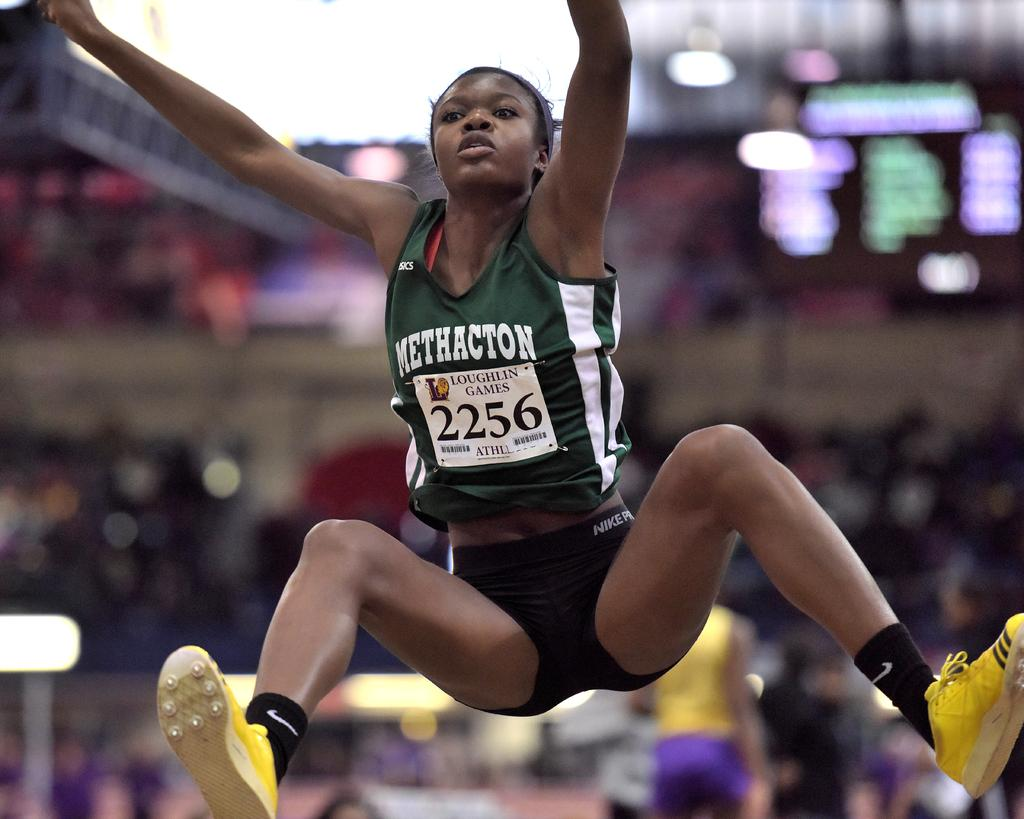<image>
Describe the image concisely. A female athlete in the Loughlin Games jumps in the air. 